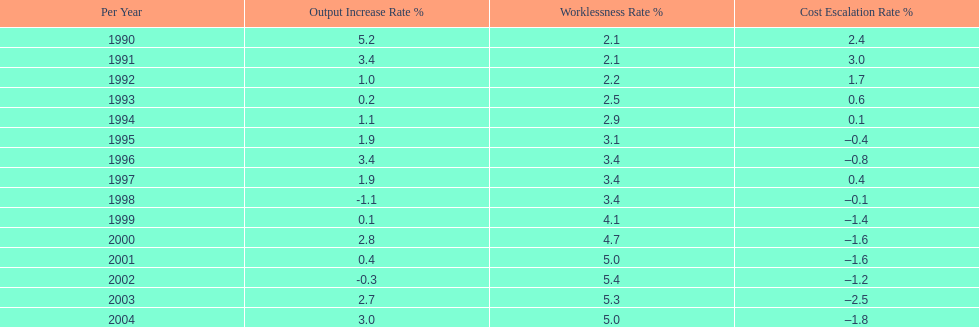I'm looking to parse the entire table for insights. Could you assist me with that? {'header': ['Per Year', 'Output Increase Rate\xa0%', 'Worklessness Rate\xa0%', 'Cost Escalation Rate\xa0%'], 'rows': [['1990', '5.2', '2.1', '2.4'], ['1991', '3.4', '2.1', '3.0'], ['1992', '1.0', '2.2', '1.7'], ['1993', '0.2', '2.5', '0.6'], ['1994', '1.1', '2.9', '0.1'], ['1995', '1.9', '3.1', '–0.4'], ['1996', '3.4', '3.4', '–0.8'], ['1997', '1.9', '3.4', '0.4'], ['1998', '-1.1', '3.4', '–0.1'], ['1999', '0.1', '4.1', '–1.4'], ['2000', '2.8', '4.7', '–1.6'], ['2001', '0.4', '5.0', '–1.6'], ['2002', '-0.3', '5.4', '–1.2'], ['2003', '2.7', '5.3', '–2.5'], ['2004', '3.0', '5.0', '–1.8']]} When in the 1990's did the inflation rate first become negative? 1995. 